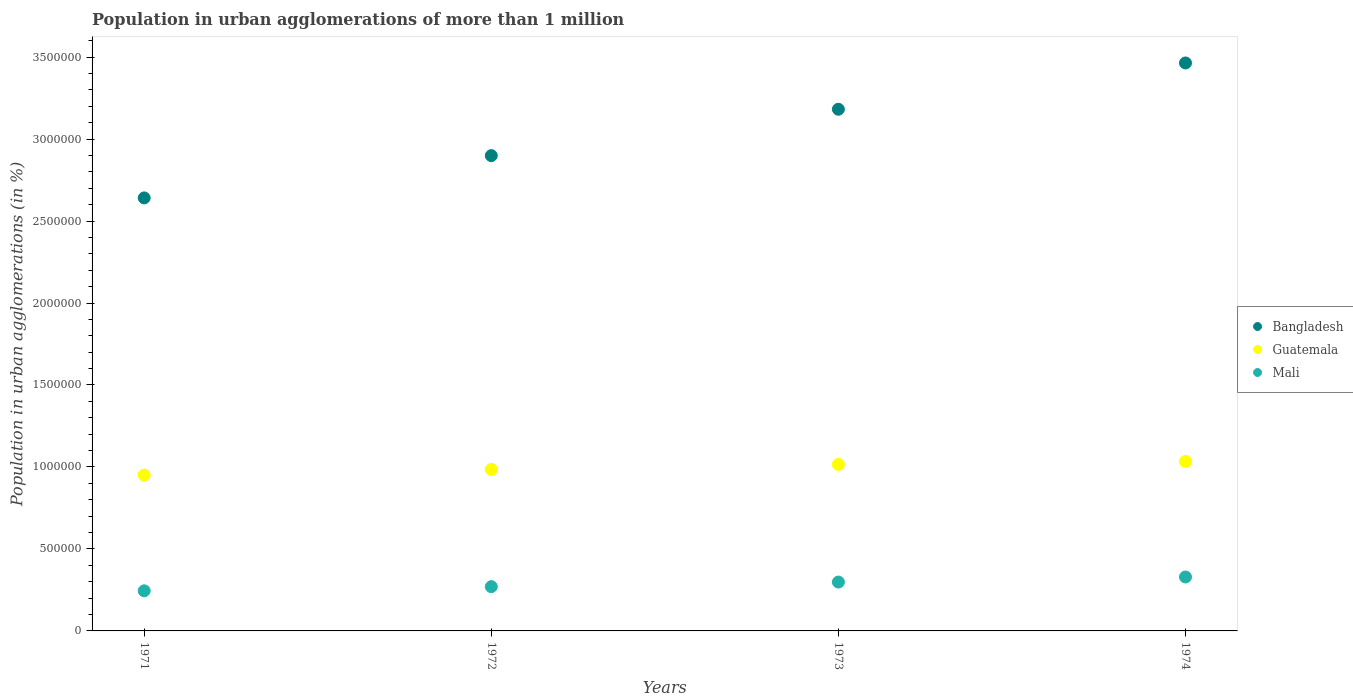How many different coloured dotlines are there?
Offer a terse response. 3. Is the number of dotlines equal to the number of legend labels?
Your answer should be very brief. Yes. What is the population in urban agglomerations in Guatemala in 1972?
Make the answer very short. 9.85e+05. Across all years, what is the maximum population in urban agglomerations in Mali?
Offer a terse response. 3.29e+05. Across all years, what is the minimum population in urban agglomerations in Mali?
Your answer should be very brief. 2.45e+05. In which year was the population in urban agglomerations in Bangladesh maximum?
Provide a succinct answer. 1974. What is the total population in urban agglomerations in Bangladesh in the graph?
Your answer should be compact. 1.22e+07. What is the difference between the population in urban agglomerations in Bangladesh in 1971 and that in 1973?
Offer a very short reply. -5.41e+05. What is the difference between the population in urban agglomerations in Mali in 1971 and the population in urban agglomerations in Guatemala in 1974?
Ensure brevity in your answer.  -7.90e+05. What is the average population in urban agglomerations in Guatemala per year?
Offer a very short reply. 9.96e+05. In the year 1972, what is the difference between the population in urban agglomerations in Mali and population in urban agglomerations in Guatemala?
Keep it short and to the point. -7.15e+05. What is the ratio of the population in urban agglomerations in Bangladesh in 1971 to that in 1974?
Offer a very short reply. 0.76. What is the difference between the highest and the second highest population in urban agglomerations in Bangladesh?
Give a very brief answer. 2.82e+05. What is the difference between the highest and the lowest population in urban agglomerations in Guatemala?
Offer a very short reply. 8.38e+04. In how many years, is the population in urban agglomerations in Mali greater than the average population in urban agglomerations in Mali taken over all years?
Provide a succinct answer. 2. Is the sum of the population in urban agglomerations in Guatemala in 1971 and 1974 greater than the maximum population in urban agglomerations in Bangladesh across all years?
Your response must be concise. No. Is it the case that in every year, the sum of the population in urban agglomerations in Mali and population in urban agglomerations in Bangladesh  is greater than the population in urban agglomerations in Guatemala?
Your response must be concise. Yes. Does the population in urban agglomerations in Mali monotonically increase over the years?
Make the answer very short. Yes. Is the population in urban agglomerations in Guatemala strictly greater than the population in urban agglomerations in Mali over the years?
Your answer should be very brief. Yes. Is the population in urban agglomerations in Mali strictly less than the population in urban agglomerations in Bangladesh over the years?
Make the answer very short. Yes. What is the difference between two consecutive major ticks on the Y-axis?
Ensure brevity in your answer.  5.00e+05. Are the values on the major ticks of Y-axis written in scientific E-notation?
Keep it short and to the point. No. What is the title of the graph?
Your response must be concise. Population in urban agglomerations of more than 1 million. Does "Dominican Republic" appear as one of the legend labels in the graph?
Ensure brevity in your answer.  No. What is the label or title of the Y-axis?
Provide a succinct answer. Population in urban agglomerations (in %). What is the Population in urban agglomerations (in %) in Bangladesh in 1971?
Offer a terse response. 2.64e+06. What is the Population in urban agglomerations (in %) of Guatemala in 1971?
Make the answer very short. 9.50e+05. What is the Population in urban agglomerations (in %) in Mali in 1971?
Give a very brief answer. 2.45e+05. What is the Population in urban agglomerations (in %) in Bangladesh in 1972?
Provide a short and direct response. 2.90e+06. What is the Population in urban agglomerations (in %) of Guatemala in 1972?
Ensure brevity in your answer.  9.85e+05. What is the Population in urban agglomerations (in %) in Mali in 1972?
Ensure brevity in your answer.  2.70e+05. What is the Population in urban agglomerations (in %) in Bangladesh in 1973?
Ensure brevity in your answer.  3.18e+06. What is the Population in urban agglomerations (in %) in Guatemala in 1973?
Offer a terse response. 1.02e+06. What is the Population in urban agglomerations (in %) of Mali in 1973?
Ensure brevity in your answer.  2.98e+05. What is the Population in urban agglomerations (in %) of Bangladesh in 1974?
Offer a terse response. 3.46e+06. What is the Population in urban agglomerations (in %) of Guatemala in 1974?
Give a very brief answer. 1.03e+06. What is the Population in urban agglomerations (in %) of Mali in 1974?
Your response must be concise. 3.29e+05. Across all years, what is the maximum Population in urban agglomerations (in %) of Bangladesh?
Offer a very short reply. 3.46e+06. Across all years, what is the maximum Population in urban agglomerations (in %) of Guatemala?
Your answer should be very brief. 1.03e+06. Across all years, what is the maximum Population in urban agglomerations (in %) in Mali?
Give a very brief answer. 3.29e+05. Across all years, what is the minimum Population in urban agglomerations (in %) in Bangladesh?
Provide a succinct answer. 2.64e+06. Across all years, what is the minimum Population in urban agglomerations (in %) in Guatemala?
Make the answer very short. 9.50e+05. Across all years, what is the minimum Population in urban agglomerations (in %) in Mali?
Your answer should be compact. 2.45e+05. What is the total Population in urban agglomerations (in %) in Bangladesh in the graph?
Provide a succinct answer. 1.22e+07. What is the total Population in urban agglomerations (in %) of Guatemala in the graph?
Offer a very short reply. 3.99e+06. What is the total Population in urban agglomerations (in %) in Mali in the graph?
Provide a short and direct response. 1.14e+06. What is the difference between the Population in urban agglomerations (in %) of Bangladesh in 1971 and that in 1972?
Offer a very short reply. -2.58e+05. What is the difference between the Population in urban agglomerations (in %) in Guatemala in 1971 and that in 1972?
Offer a very short reply. -3.45e+04. What is the difference between the Population in urban agglomerations (in %) of Mali in 1971 and that in 1972?
Provide a succinct answer. -2.54e+04. What is the difference between the Population in urban agglomerations (in %) in Bangladesh in 1971 and that in 1973?
Ensure brevity in your answer.  -5.41e+05. What is the difference between the Population in urban agglomerations (in %) in Guatemala in 1971 and that in 1973?
Give a very brief answer. -6.54e+04. What is the difference between the Population in urban agglomerations (in %) of Mali in 1971 and that in 1973?
Make the answer very short. -5.34e+04. What is the difference between the Population in urban agglomerations (in %) of Bangladesh in 1971 and that in 1974?
Your response must be concise. -8.23e+05. What is the difference between the Population in urban agglomerations (in %) of Guatemala in 1971 and that in 1974?
Your response must be concise. -8.38e+04. What is the difference between the Population in urban agglomerations (in %) of Mali in 1971 and that in 1974?
Give a very brief answer. -8.43e+04. What is the difference between the Population in urban agglomerations (in %) in Bangladesh in 1972 and that in 1973?
Your response must be concise. -2.83e+05. What is the difference between the Population in urban agglomerations (in %) of Guatemala in 1972 and that in 1973?
Provide a succinct answer. -3.09e+04. What is the difference between the Population in urban agglomerations (in %) in Mali in 1972 and that in 1973?
Your response must be concise. -2.80e+04. What is the difference between the Population in urban agglomerations (in %) in Bangladesh in 1972 and that in 1974?
Offer a terse response. -5.65e+05. What is the difference between the Population in urban agglomerations (in %) in Guatemala in 1972 and that in 1974?
Offer a very short reply. -4.94e+04. What is the difference between the Population in urban agglomerations (in %) in Mali in 1972 and that in 1974?
Make the answer very short. -5.89e+04. What is the difference between the Population in urban agglomerations (in %) in Bangladesh in 1973 and that in 1974?
Give a very brief answer. -2.82e+05. What is the difference between the Population in urban agglomerations (in %) in Guatemala in 1973 and that in 1974?
Provide a succinct answer. -1.85e+04. What is the difference between the Population in urban agglomerations (in %) of Mali in 1973 and that in 1974?
Make the answer very short. -3.09e+04. What is the difference between the Population in urban agglomerations (in %) in Bangladesh in 1971 and the Population in urban agglomerations (in %) in Guatemala in 1972?
Provide a succinct answer. 1.66e+06. What is the difference between the Population in urban agglomerations (in %) in Bangladesh in 1971 and the Population in urban agglomerations (in %) in Mali in 1972?
Make the answer very short. 2.37e+06. What is the difference between the Population in urban agglomerations (in %) in Guatemala in 1971 and the Population in urban agglomerations (in %) in Mali in 1972?
Ensure brevity in your answer.  6.80e+05. What is the difference between the Population in urban agglomerations (in %) of Bangladesh in 1971 and the Population in urban agglomerations (in %) of Guatemala in 1973?
Offer a very short reply. 1.63e+06. What is the difference between the Population in urban agglomerations (in %) in Bangladesh in 1971 and the Population in urban agglomerations (in %) in Mali in 1973?
Ensure brevity in your answer.  2.34e+06. What is the difference between the Population in urban agglomerations (in %) in Guatemala in 1971 and the Population in urban agglomerations (in %) in Mali in 1973?
Provide a succinct answer. 6.52e+05. What is the difference between the Population in urban agglomerations (in %) of Bangladesh in 1971 and the Population in urban agglomerations (in %) of Guatemala in 1974?
Your answer should be very brief. 1.61e+06. What is the difference between the Population in urban agglomerations (in %) in Bangladesh in 1971 and the Population in urban agglomerations (in %) in Mali in 1974?
Your answer should be very brief. 2.31e+06. What is the difference between the Population in urban agglomerations (in %) of Guatemala in 1971 and the Population in urban agglomerations (in %) of Mali in 1974?
Your answer should be very brief. 6.21e+05. What is the difference between the Population in urban agglomerations (in %) of Bangladesh in 1972 and the Population in urban agglomerations (in %) of Guatemala in 1973?
Your answer should be compact. 1.88e+06. What is the difference between the Population in urban agglomerations (in %) of Bangladesh in 1972 and the Population in urban agglomerations (in %) of Mali in 1973?
Provide a short and direct response. 2.60e+06. What is the difference between the Population in urban agglomerations (in %) of Guatemala in 1972 and the Population in urban agglomerations (in %) of Mali in 1973?
Make the answer very short. 6.87e+05. What is the difference between the Population in urban agglomerations (in %) in Bangladesh in 1972 and the Population in urban agglomerations (in %) in Guatemala in 1974?
Give a very brief answer. 1.86e+06. What is the difference between the Population in urban agglomerations (in %) in Bangladesh in 1972 and the Population in urban agglomerations (in %) in Mali in 1974?
Provide a succinct answer. 2.57e+06. What is the difference between the Population in urban agglomerations (in %) of Guatemala in 1972 and the Population in urban agglomerations (in %) of Mali in 1974?
Provide a succinct answer. 6.56e+05. What is the difference between the Population in urban agglomerations (in %) in Bangladesh in 1973 and the Population in urban agglomerations (in %) in Guatemala in 1974?
Give a very brief answer. 2.15e+06. What is the difference between the Population in urban agglomerations (in %) in Bangladesh in 1973 and the Population in urban agglomerations (in %) in Mali in 1974?
Ensure brevity in your answer.  2.85e+06. What is the difference between the Population in urban agglomerations (in %) of Guatemala in 1973 and the Population in urban agglomerations (in %) of Mali in 1974?
Ensure brevity in your answer.  6.87e+05. What is the average Population in urban agglomerations (in %) in Bangladesh per year?
Your response must be concise. 3.05e+06. What is the average Population in urban agglomerations (in %) of Guatemala per year?
Your answer should be very brief. 9.96e+05. What is the average Population in urban agglomerations (in %) in Mali per year?
Keep it short and to the point. 2.85e+05. In the year 1971, what is the difference between the Population in urban agglomerations (in %) in Bangladesh and Population in urban agglomerations (in %) in Guatemala?
Your answer should be very brief. 1.69e+06. In the year 1971, what is the difference between the Population in urban agglomerations (in %) in Bangladesh and Population in urban agglomerations (in %) in Mali?
Offer a very short reply. 2.40e+06. In the year 1971, what is the difference between the Population in urban agglomerations (in %) of Guatemala and Population in urban agglomerations (in %) of Mali?
Offer a terse response. 7.06e+05. In the year 1972, what is the difference between the Population in urban agglomerations (in %) in Bangladesh and Population in urban agglomerations (in %) in Guatemala?
Your answer should be compact. 1.91e+06. In the year 1972, what is the difference between the Population in urban agglomerations (in %) in Bangladesh and Population in urban agglomerations (in %) in Mali?
Offer a very short reply. 2.63e+06. In the year 1972, what is the difference between the Population in urban agglomerations (in %) of Guatemala and Population in urban agglomerations (in %) of Mali?
Keep it short and to the point. 7.15e+05. In the year 1973, what is the difference between the Population in urban agglomerations (in %) of Bangladesh and Population in urban agglomerations (in %) of Guatemala?
Keep it short and to the point. 2.17e+06. In the year 1973, what is the difference between the Population in urban agglomerations (in %) of Bangladesh and Population in urban agglomerations (in %) of Mali?
Keep it short and to the point. 2.88e+06. In the year 1973, what is the difference between the Population in urban agglomerations (in %) in Guatemala and Population in urban agglomerations (in %) in Mali?
Give a very brief answer. 7.18e+05. In the year 1974, what is the difference between the Population in urban agglomerations (in %) of Bangladesh and Population in urban agglomerations (in %) of Guatemala?
Your answer should be compact. 2.43e+06. In the year 1974, what is the difference between the Population in urban agglomerations (in %) of Bangladesh and Population in urban agglomerations (in %) of Mali?
Your answer should be compact. 3.14e+06. In the year 1974, what is the difference between the Population in urban agglomerations (in %) in Guatemala and Population in urban agglomerations (in %) in Mali?
Offer a terse response. 7.05e+05. What is the ratio of the Population in urban agglomerations (in %) in Bangladesh in 1971 to that in 1972?
Provide a short and direct response. 0.91. What is the ratio of the Population in urban agglomerations (in %) in Guatemala in 1971 to that in 1972?
Your answer should be very brief. 0.96. What is the ratio of the Population in urban agglomerations (in %) in Mali in 1971 to that in 1972?
Give a very brief answer. 0.91. What is the ratio of the Population in urban agglomerations (in %) of Bangladesh in 1971 to that in 1973?
Offer a very short reply. 0.83. What is the ratio of the Population in urban agglomerations (in %) in Guatemala in 1971 to that in 1973?
Offer a very short reply. 0.94. What is the ratio of the Population in urban agglomerations (in %) in Mali in 1971 to that in 1973?
Offer a terse response. 0.82. What is the ratio of the Population in urban agglomerations (in %) in Bangladesh in 1971 to that in 1974?
Keep it short and to the point. 0.76. What is the ratio of the Population in urban agglomerations (in %) in Guatemala in 1971 to that in 1974?
Keep it short and to the point. 0.92. What is the ratio of the Population in urban agglomerations (in %) of Mali in 1971 to that in 1974?
Provide a short and direct response. 0.74. What is the ratio of the Population in urban agglomerations (in %) of Bangladesh in 1972 to that in 1973?
Keep it short and to the point. 0.91. What is the ratio of the Population in urban agglomerations (in %) of Guatemala in 1972 to that in 1973?
Offer a very short reply. 0.97. What is the ratio of the Population in urban agglomerations (in %) in Mali in 1972 to that in 1973?
Keep it short and to the point. 0.91. What is the ratio of the Population in urban agglomerations (in %) of Bangladesh in 1972 to that in 1974?
Provide a succinct answer. 0.84. What is the ratio of the Population in urban agglomerations (in %) in Guatemala in 1972 to that in 1974?
Your answer should be compact. 0.95. What is the ratio of the Population in urban agglomerations (in %) in Mali in 1972 to that in 1974?
Ensure brevity in your answer.  0.82. What is the ratio of the Population in urban agglomerations (in %) in Bangladesh in 1973 to that in 1974?
Offer a very short reply. 0.92. What is the ratio of the Population in urban agglomerations (in %) of Guatemala in 1973 to that in 1974?
Provide a short and direct response. 0.98. What is the ratio of the Population in urban agglomerations (in %) of Mali in 1973 to that in 1974?
Your response must be concise. 0.91. What is the difference between the highest and the second highest Population in urban agglomerations (in %) in Bangladesh?
Provide a succinct answer. 2.82e+05. What is the difference between the highest and the second highest Population in urban agglomerations (in %) of Guatemala?
Offer a terse response. 1.85e+04. What is the difference between the highest and the second highest Population in urban agglomerations (in %) of Mali?
Offer a terse response. 3.09e+04. What is the difference between the highest and the lowest Population in urban agglomerations (in %) in Bangladesh?
Offer a terse response. 8.23e+05. What is the difference between the highest and the lowest Population in urban agglomerations (in %) in Guatemala?
Provide a succinct answer. 8.38e+04. What is the difference between the highest and the lowest Population in urban agglomerations (in %) of Mali?
Your answer should be compact. 8.43e+04. 